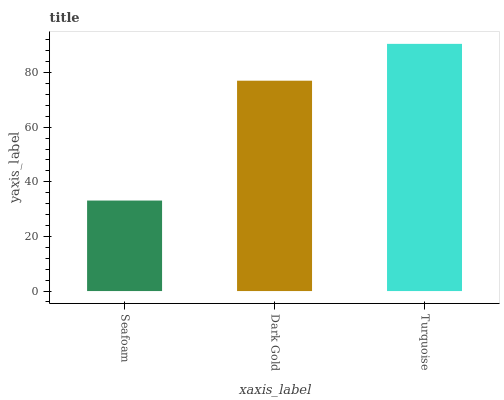Is Dark Gold the minimum?
Answer yes or no. No. Is Dark Gold the maximum?
Answer yes or no. No. Is Dark Gold greater than Seafoam?
Answer yes or no. Yes. Is Seafoam less than Dark Gold?
Answer yes or no. Yes. Is Seafoam greater than Dark Gold?
Answer yes or no. No. Is Dark Gold less than Seafoam?
Answer yes or no. No. Is Dark Gold the high median?
Answer yes or no. Yes. Is Dark Gold the low median?
Answer yes or no. Yes. Is Turquoise the high median?
Answer yes or no. No. Is Seafoam the low median?
Answer yes or no. No. 